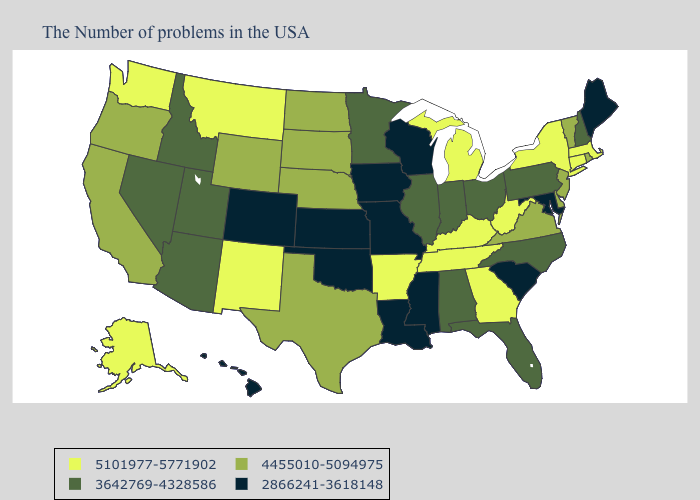How many symbols are there in the legend?
Short answer required. 4. Name the states that have a value in the range 4455010-5094975?
Give a very brief answer. Rhode Island, Vermont, New Jersey, Delaware, Virginia, Nebraska, Texas, South Dakota, North Dakota, Wyoming, California, Oregon. What is the value of Alaska?
Be succinct. 5101977-5771902. Does Wyoming have the highest value in the West?
Quick response, please. No. Does Idaho have the same value as Missouri?
Quick response, please. No. What is the value of Oklahoma?
Short answer required. 2866241-3618148. What is the value of Missouri?
Concise answer only. 2866241-3618148. Does Georgia have the highest value in the USA?
Write a very short answer. Yes. Does Maine have the lowest value in the USA?
Short answer required. Yes. Name the states that have a value in the range 5101977-5771902?
Be succinct. Massachusetts, Connecticut, New York, West Virginia, Georgia, Michigan, Kentucky, Tennessee, Arkansas, New Mexico, Montana, Washington, Alaska. What is the value of New Hampshire?
Be succinct. 3642769-4328586. Does Wyoming have the highest value in the USA?
Keep it brief. No. Does the map have missing data?
Answer briefly. No. Among the states that border Arkansas , which have the lowest value?
Be succinct. Mississippi, Louisiana, Missouri, Oklahoma. 